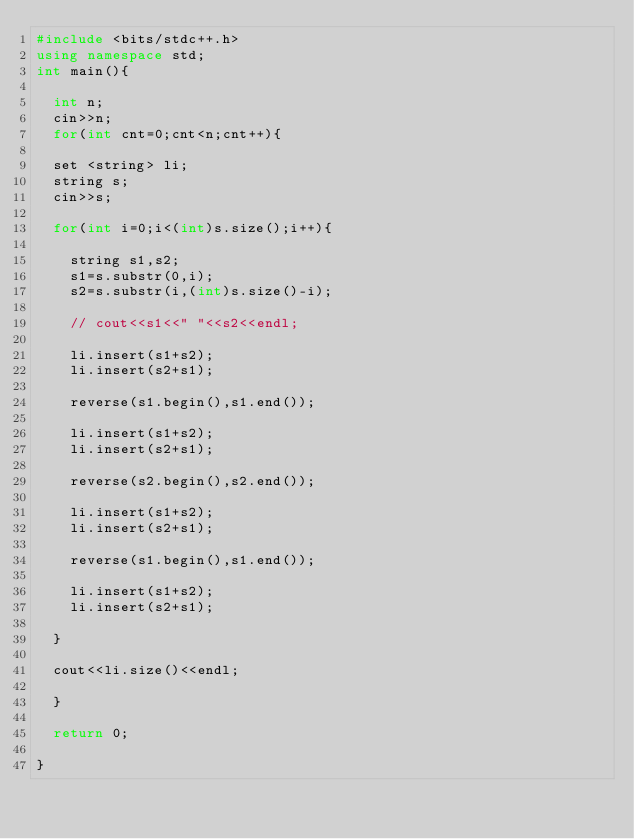<code> <loc_0><loc_0><loc_500><loc_500><_C++_>#include <bits/stdc++.h>
using namespace std;
int main(){

  int n;
  cin>>n;
  for(int cnt=0;cnt<n;cnt++){

  set <string> li;
  string s;
  cin>>s;

  for(int i=0;i<(int)s.size();i++){

    string s1,s2;
    s1=s.substr(0,i);
    s2=s.substr(i,(int)s.size()-i);

    // cout<<s1<<" "<<s2<<endl;

    li.insert(s1+s2);
    li.insert(s2+s1);

    reverse(s1.begin(),s1.end());

    li.insert(s1+s2);
    li.insert(s2+s1);

    reverse(s2.begin(),s2.end());

    li.insert(s1+s2);
    li.insert(s2+s1);

    reverse(s1.begin(),s1.end());

    li.insert(s1+s2);
    li.insert(s2+s1);

  }

  cout<<li.size()<<endl;

  }

  return 0;

}

</code> 